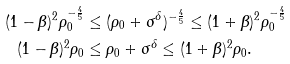<formula> <loc_0><loc_0><loc_500><loc_500>( 1 - \beta ) ^ { 2 } \rho _ { 0 } ^ { - \frac { 4 } { 5 } } & \leq ( \rho _ { 0 } + \sigma ^ { \delta } ) ^ { - \frac { 4 } { 5 } } \leq ( 1 + \beta ) ^ { 2 } \rho _ { 0 } ^ { - \frac { 4 } { 5 } } \\ ( 1 - \beta ) ^ { 2 } \rho _ { 0 } & \leq \rho _ { 0 } + \sigma ^ { \delta } \leq ( 1 + \beta ) ^ { 2 } \rho _ { 0 } .</formula> 